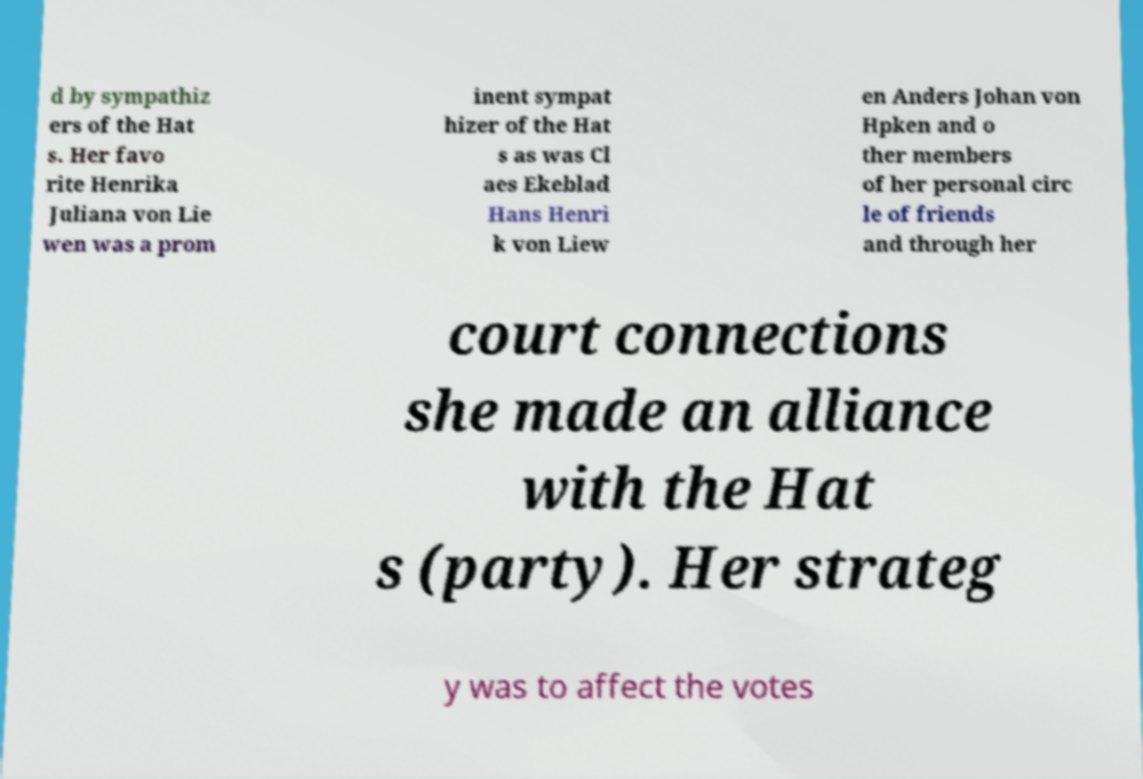Can you accurately transcribe the text from the provided image for me? d by sympathiz ers of the Hat s. Her favo rite Henrika Juliana von Lie wen was a prom inent sympat hizer of the Hat s as was Cl aes Ekeblad Hans Henri k von Liew en Anders Johan von Hpken and o ther members of her personal circ le of friends and through her court connections she made an alliance with the Hat s (party). Her strateg y was to affect the votes 